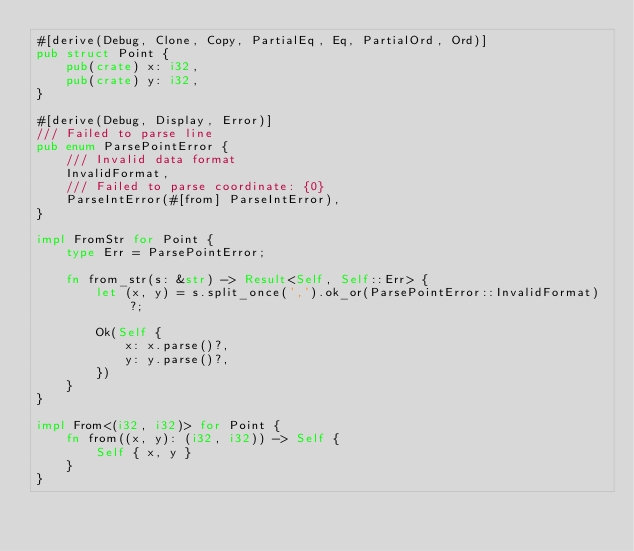Convert code to text. <code><loc_0><loc_0><loc_500><loc_500><_Rust_>#[derive(Debug, Clone, Copy, PartialEq, Eq, PartialOrd, Ord)]
pub struct Point {
    pub(crate) x: i32,
    pub(crate) y: i32,
}

#[derive(Debug, Display, Error)]
/// Failed to parse line
pub enum ParsePointError {
    /// Invalid data format
    InvalidFormat,
    /// Failed to parse coordinate: {0}
    ParseIntError(#[from] ParseIntError),
}

impl FromStr for Point {
    type Err = ParsePointError;

    fn from_str(s: &str) -> Result<Self, Self::Err> {
        let (x, y) = s.split_once(',').ok_or(ParsePointError::InvalidFormat)?;

        Ok(Self {
            x: x.parse()?,
            y: y.parse()?,
        })
    }
}

impl From<(i32, i32)> for Point {
    fn from((x, y): (i32, i32)) -> Self {
        Self { x, y }
    }
}
</code> 